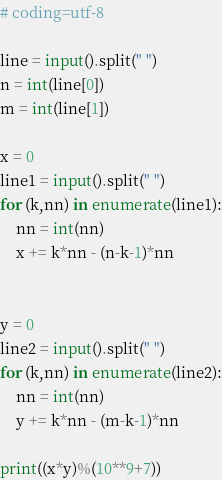<code> <loc_0><loc_0><loc_500><loc_500><_Python_># coding=utf-8

line = input().split(" ")
n = int(line[0])
m = int(line[1])

x = 0
line1 = input().split(" ")
for (k,nn) in enumerate(line1):
    nn = int(nn)
    x += k*nn - (n-k-1)*nn


y = 0
line2 = input().split(" ")
for (k,nn) in enumerate(line2):
    nn = int(nn)
    y += k*nn - (m-k-1)*nn

print((x*y)%(10**9+7))
</code> 